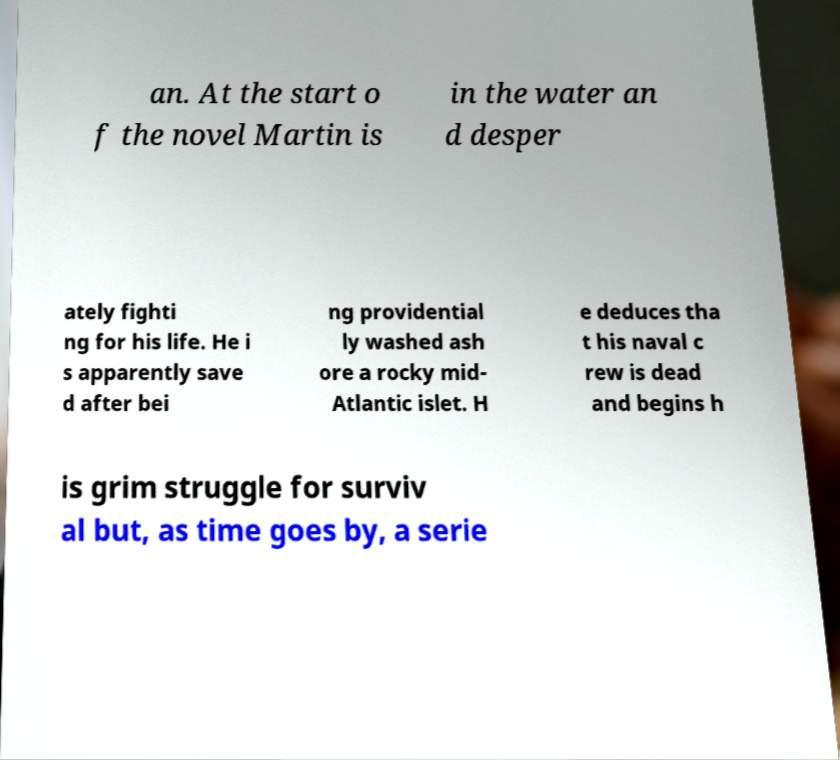Can you read and provide the text displayed in the image?This photo seems to have some interesting text. Can you extract and type it out for me? an. At the start o f the novel Martin is in the water an d desper ately fighti ng for his life. He i s apparently save d after bei ng providential ly washed ash ore a rocky mid- Atlantic islet. H e deduces tha t his naval c rew is dead and begins h is grim struggle for surviv al but, as time goes by, a serie 